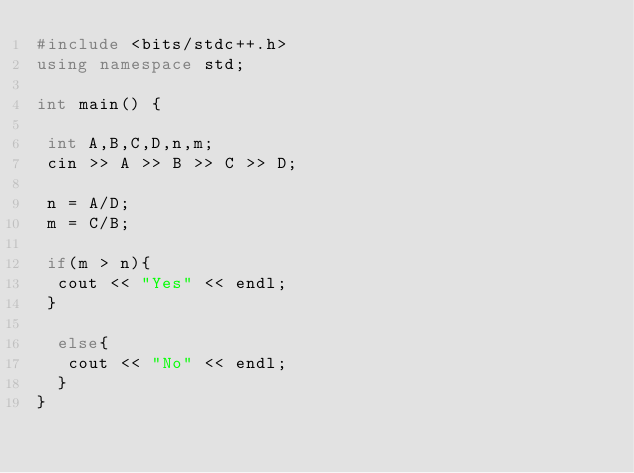Convert code to text. <code><loc_0><loc_0><loc_500><loc_500><_C++_>#include <bits/stdc++.h>
using namespace std;

int main() {

 int A,B,C,D,n,m;
 cin >> A >> B >> C >> D;
  
 n = A/D;
 m = C/B;
  
 if(m > n){
  cout << "Yes" << endl; 
 }
  
  else{
   cout << "No" << endl; 
  }
}</code> 